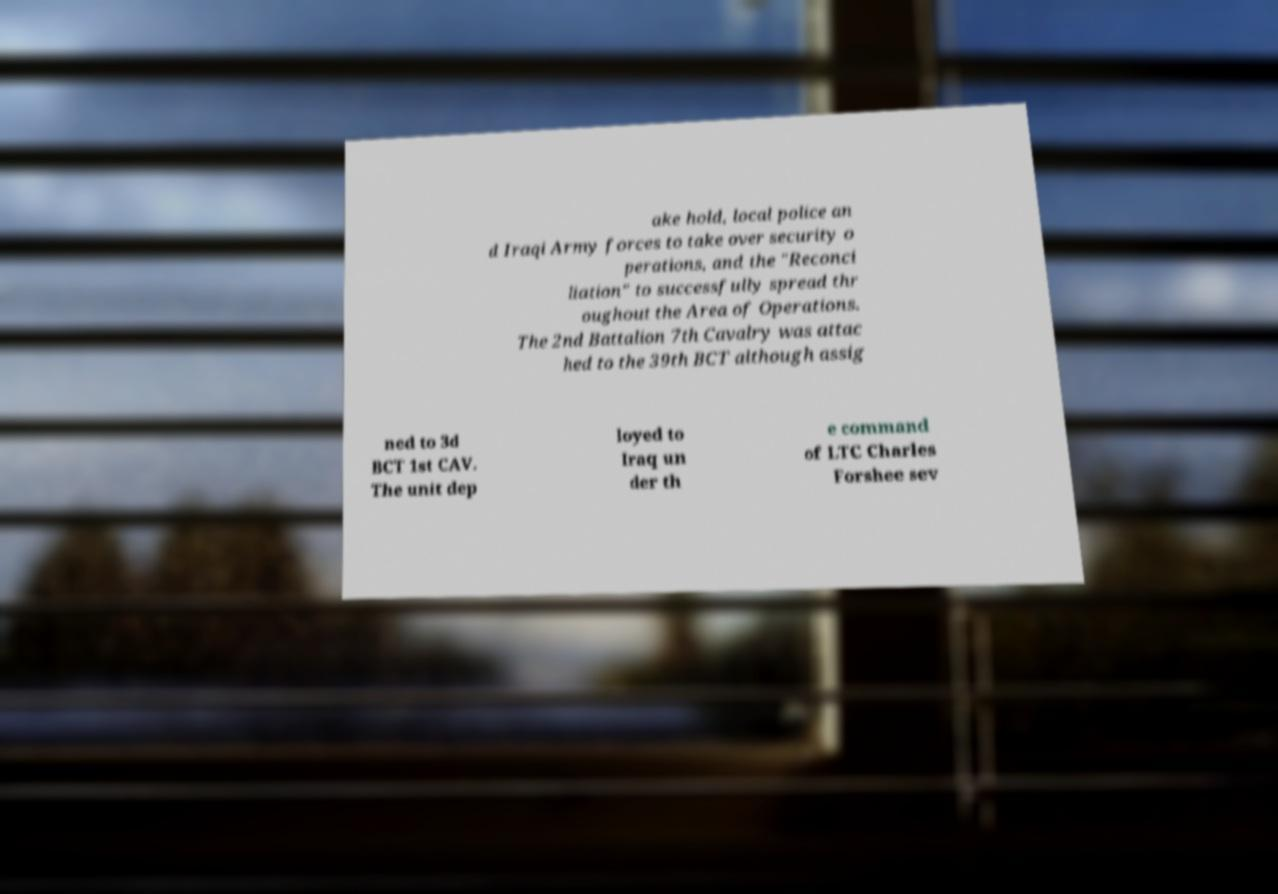Could you extract and type out the text from this image? ake hold, local police an d Iraqi Army forces to take over security o perations, and the "Reconci liation" to successfully spread thr oughout the Area of Operations. The 2nd Battalion 7th Cavalry was attac hed to the 39th BCT although assig ned to 3d BCT 1st CAV. The unit dep loyed to Iraq un der th e command of LTC Charles Forshee sev 